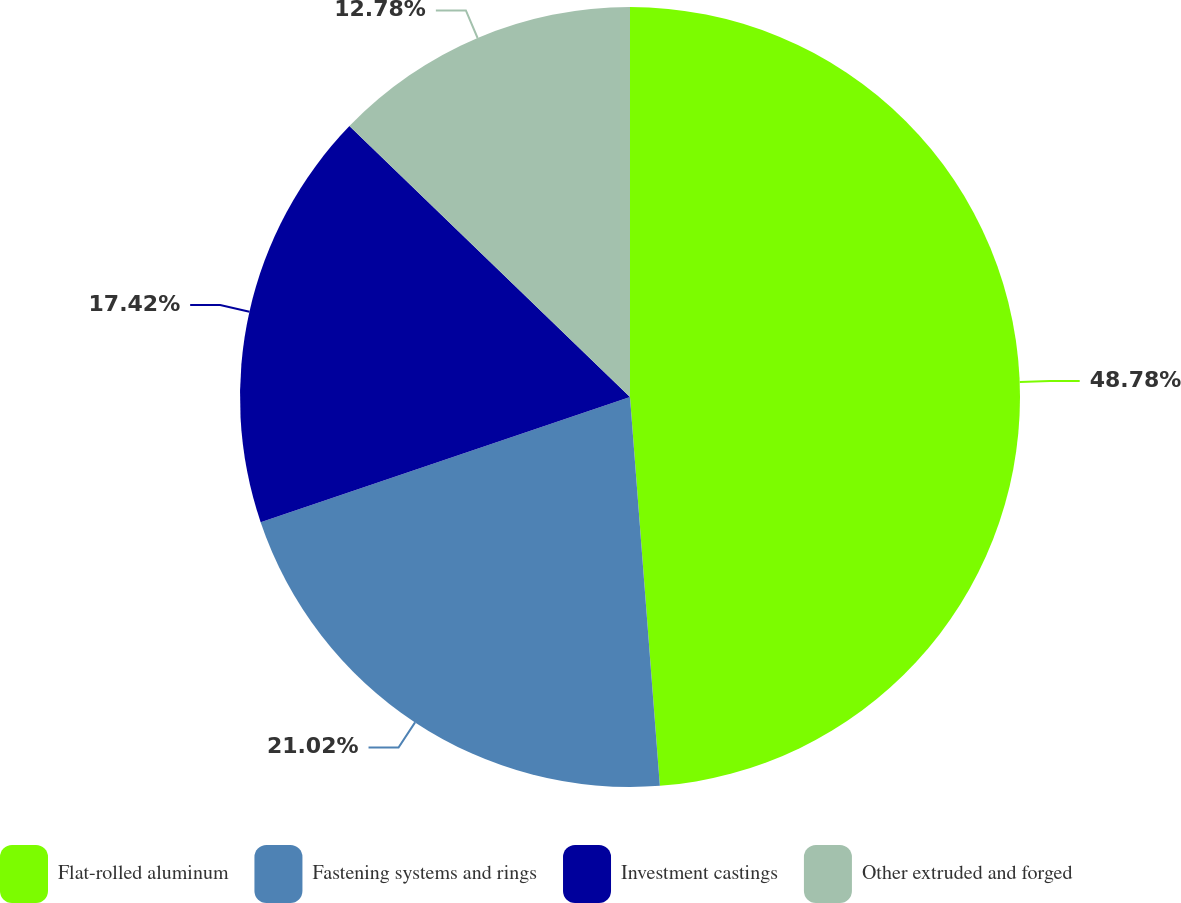Convert chart. <chart><loc_0><loc_0><loc_500><loc_500><pie_chart><fcel>Flat-rolled aluminum<fcel>Fastening systems and rings<fcel>Investment castings<fcel>Other extruded and forged<nl><fcel>48.78%<fcel>21.02%<fcel>17.42%<fcel>12.78%<nl></chart> 